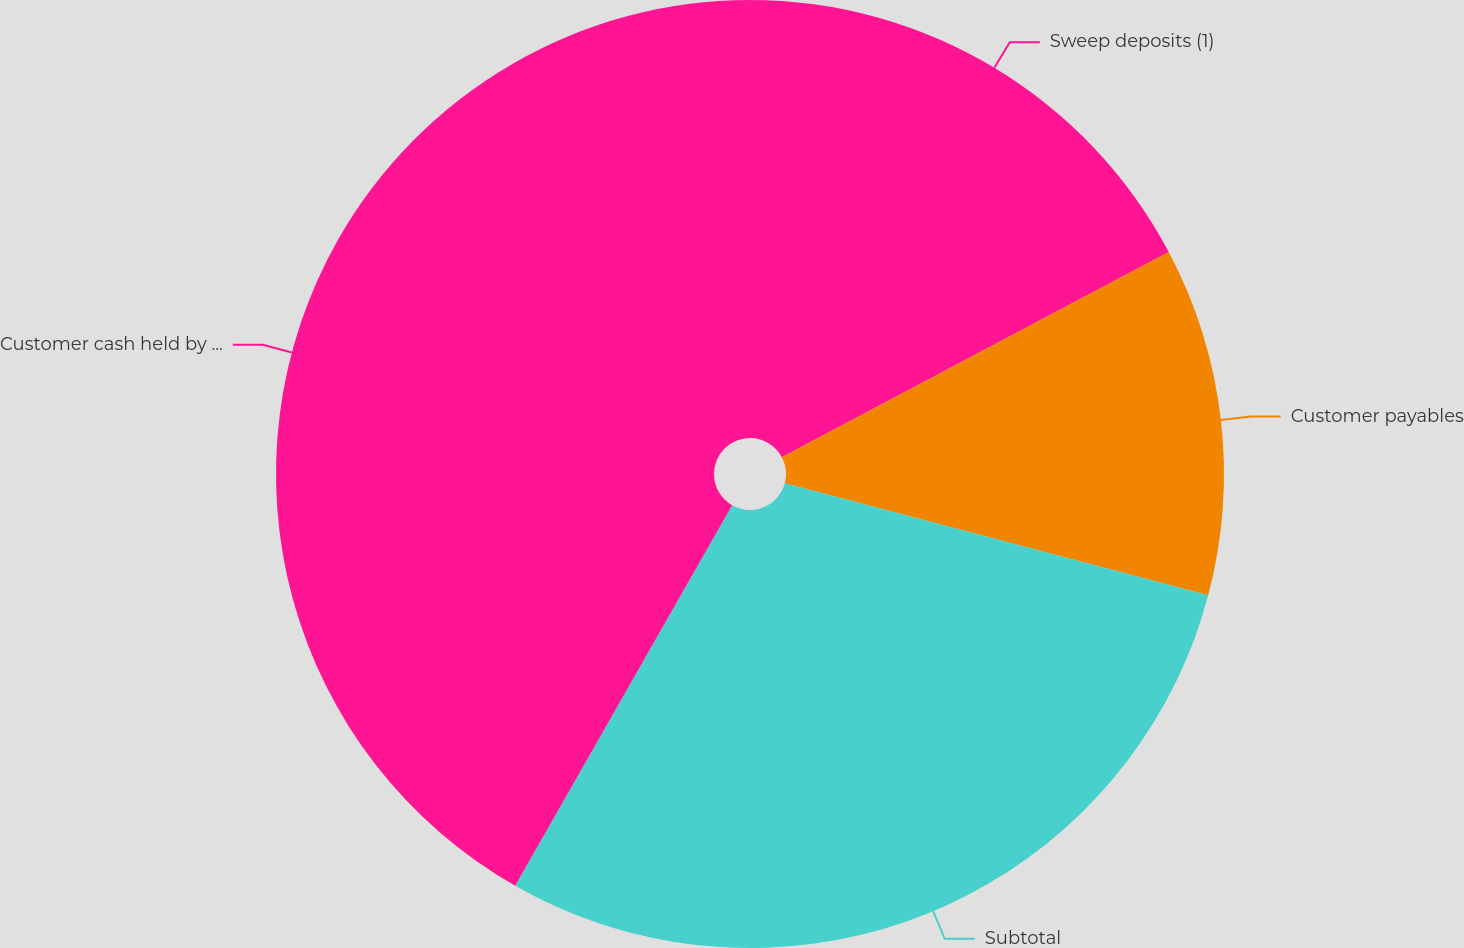<chart> <loc_0><loc_0><loc_500><loc_500><pie_chart><fcel>Sweep deposits (1)<fcel>Customer payables<fcel>Subtotal<fcel>Customer cash held by third<nl><fcel>17.24%<fcel>11.88%<fcel>29.13%<fcel>41.75%<nl></chart> 